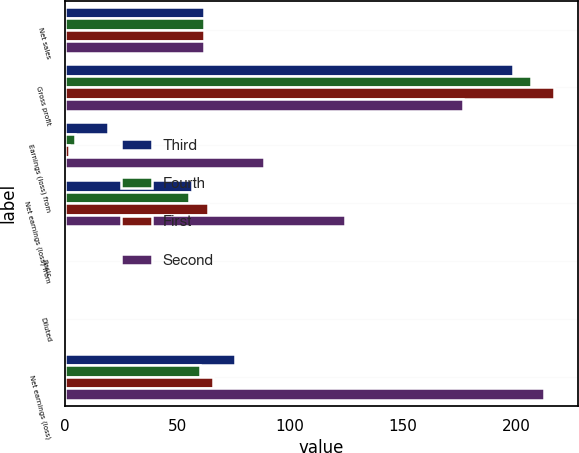Convert chart. <chart><loc_0><loc_0><loc_500><loc_500><stacked_bar_chart><ecel><fcel>Net sales<fcel>Gross profit<fcel>Earnings (loss) from<fcel>Net earnings (loss) from<fcel>Basic<fcel>Diluted<fcel>Net earnings (loss)<nl><fcel>Third<fcel>61.8<fcel>198.6<fcel>19.2<fcel>56.5<fcel>0.31<fcel>0.31<fcel>75.7<nl><fcel>Fourth<fcel>61.8<fcel>206.8<fcel>4.8<fcel>55.2<fcel>0.3<fcel>0.3<fcel>60<nl><fcel>First<fcel>61.8<fcel>216.8<fcel>2.1<fcel>63.6<fcel>0.36<fcel>0.36<fcel>65.7<nl><fcel>Second<fcel>61.8<fcel>176.4<fcel>88.3<fcel>124.3<fcel>0.71<fcel>0.71<fcel>212.6<nl></chart> 